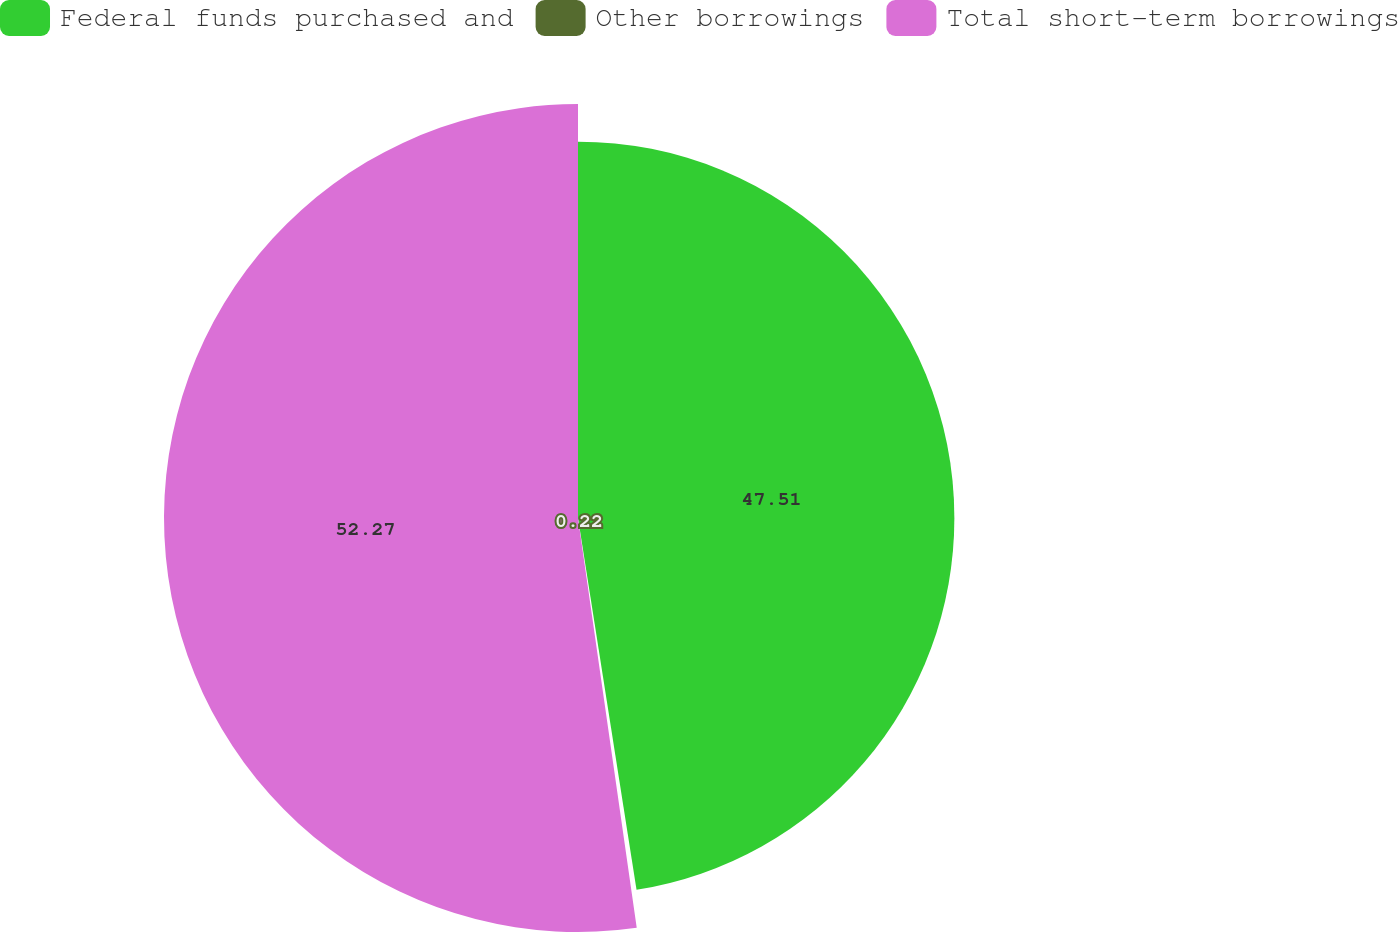Convert chart. <chart><loc_0><loc_0><loc_500><loc_500><pie_chart><fcel>Federal funds purchased and<fcel>Other borrowings<fcel>Total short-term borrowings<nl><fcel>47.51%<fcel>0.22%<fcel>52.26%<nl></chart> 